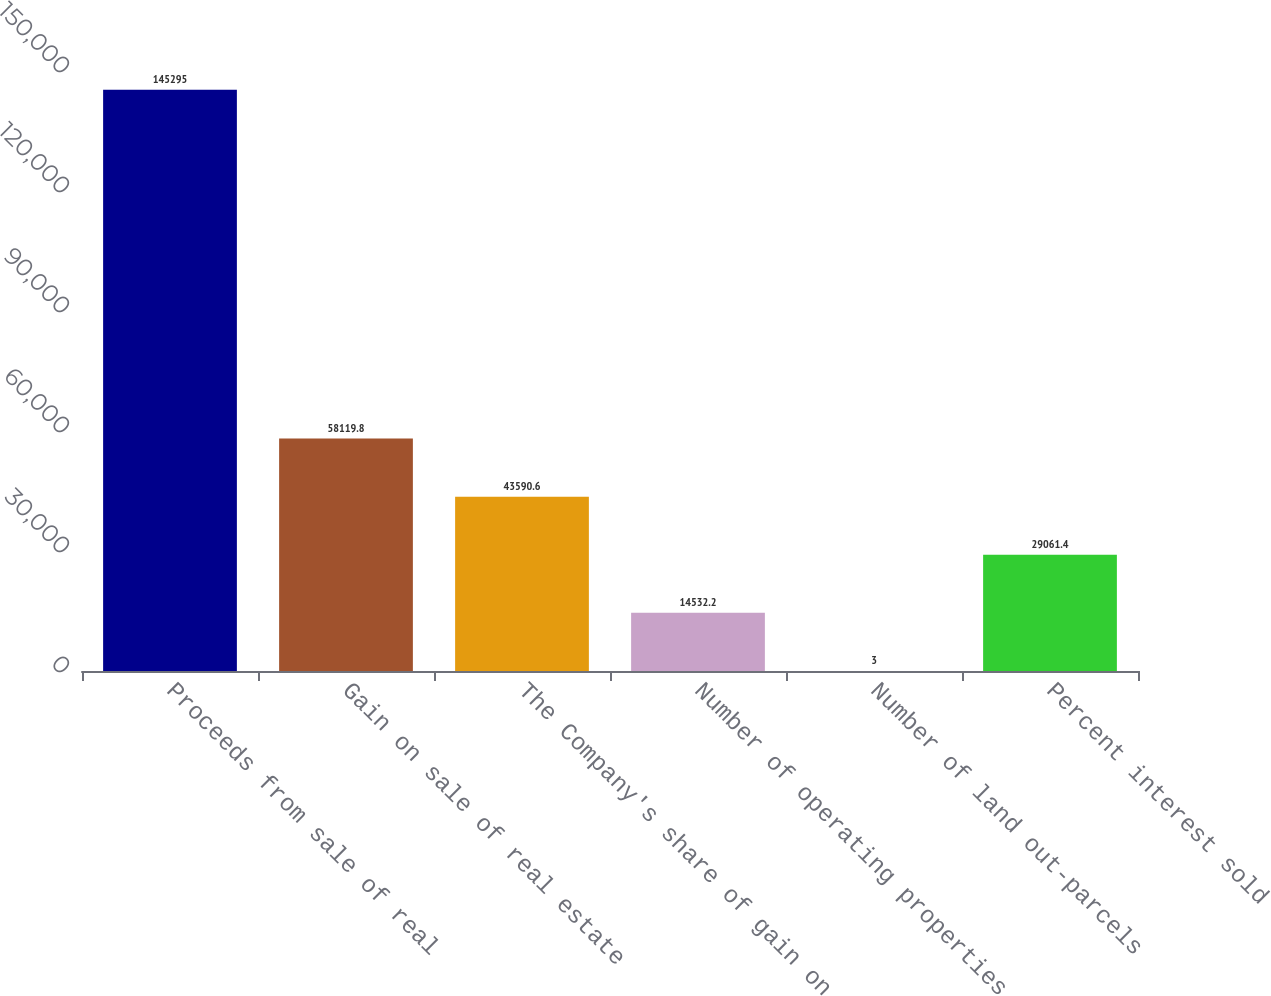<chart> <loc_0><loc_0><loc_500><loc_500><bar_chart><fcel>Proceeds from sale of real<fcel>Gain on sale of real estate<fcel>The Company's share of gain on<fcel>Number of operating properties<fcel>Number of land out-parcels<fcel>Percent interest sold<nl><fcel>145295<fcel>58119.8<fcel>43590.6<fcel>14532.2<fcel>3<fcel>29061.4<nl></chart> 